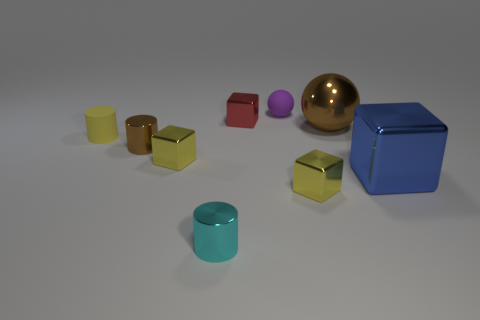What is the brown thing on the left side of the small cyan metallic cylinder made of?
Your answer should be compact. Metal. The thing that is the same color as the large metal sphere is what size?
Offer a terse response. Small. How many objects are tiny blocks that are in front of the big block or tiny red metallic cubes?
Offer a terse response. 2. Are there an equal number of small blocks in front of the small red block and large blue cubes?
Keep it short and to the point. No. Does the blue metal thing have the same size as the cyan metallic thing?
Give a very brief answer. No. There is a metallic cylinder that is the same size as the cyan thing; what is its color?
Provide a succinct answer. Brown. There is a matte ball; is its size the same as the red thing that is in front of the tiny purple thing?
Provide a succinct answer. Yes. How many tiny rubber balls are the same color as the large cube?
Your answer should be compact. 0. How many things are spheres or yellow blocks on the left side of the tiny sphere?
Your response must be concise. 3. There is a ball right of the purple thing; is it the same size as the yellow metal thing on the left side of the tiny purple object?
Your response must be concise. No. 